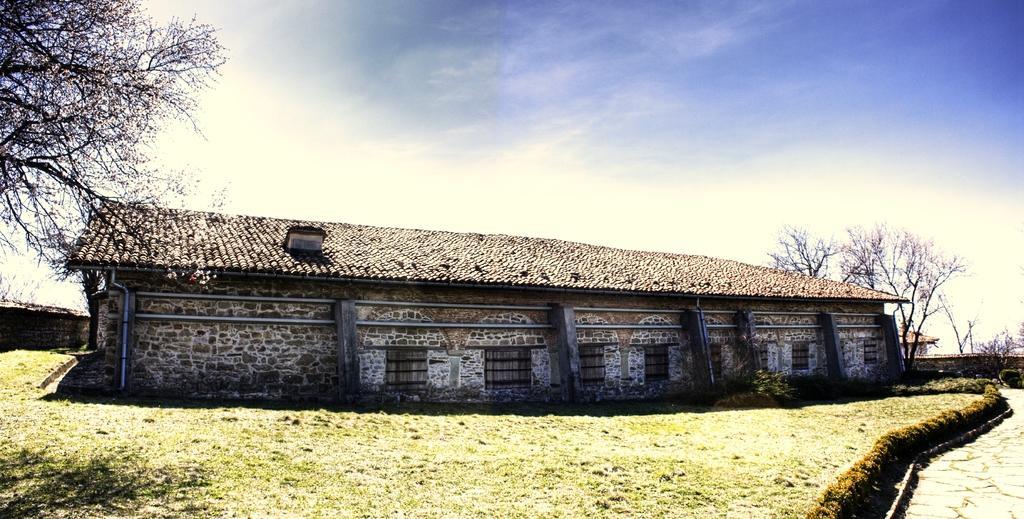Can you describe this image briefly? In this image I can see a house which is made of rocks, few pipes, some grass, few plants and the road. In the background I can see few trees, few other buildings and the sky. 